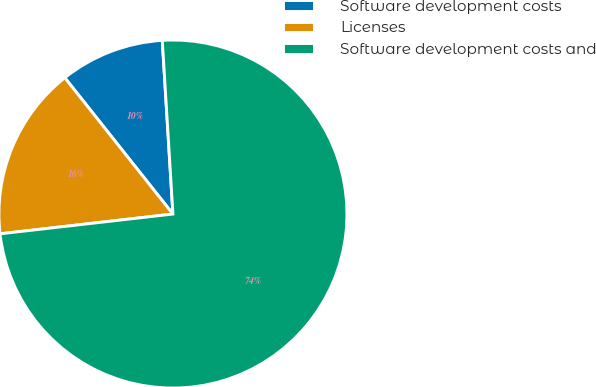Convert chart. <chart><loc_0><loc_0><loc_500><loc_500><pie_chart><fcel>Software development costs<fcel>Licenses<fcel>Software development costs and<nl><fcel>9.7%<fcel>16.14%<fcel>74.16%<nl></chart> 